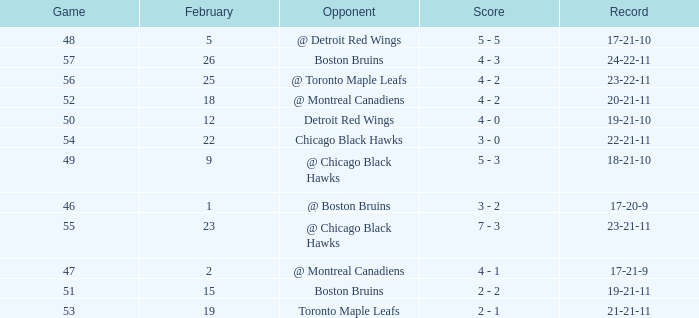What is the score of the game before 56 held after February 18 against the Chicago Black Hawks. 3 - 0. 